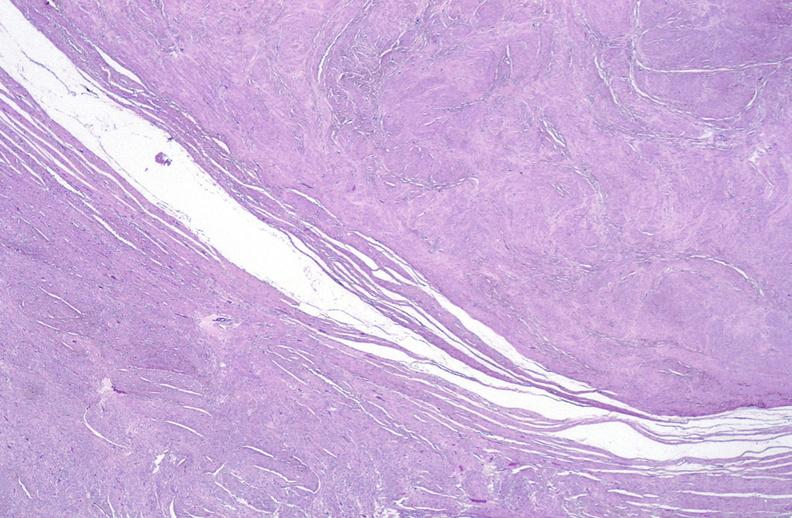does this image show leiomyoma, uterus?
Answer the question using a single word or phrase. Yes 